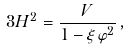Convert formula to latex. <formula><loc_0><loc_0><loc_500><loc_500>3 H ^ { 2 } = \frac { V } { 1 - \xi \varphi ^ { 2 } } \, ,</formula> 